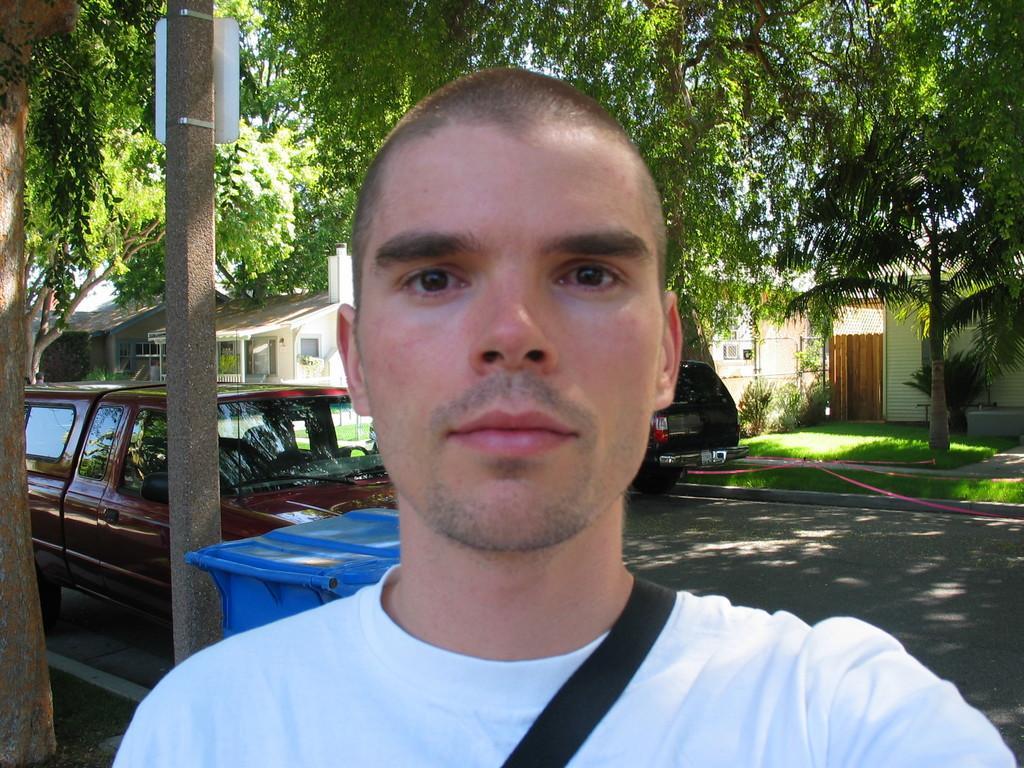In one or two sentences, can you explain what this image depicts? In this image, we can see a person. There are a few vehicles and buildings. We can also see the ground, a pipe. We can see some grass. There are a few trees and a pole with a board. 